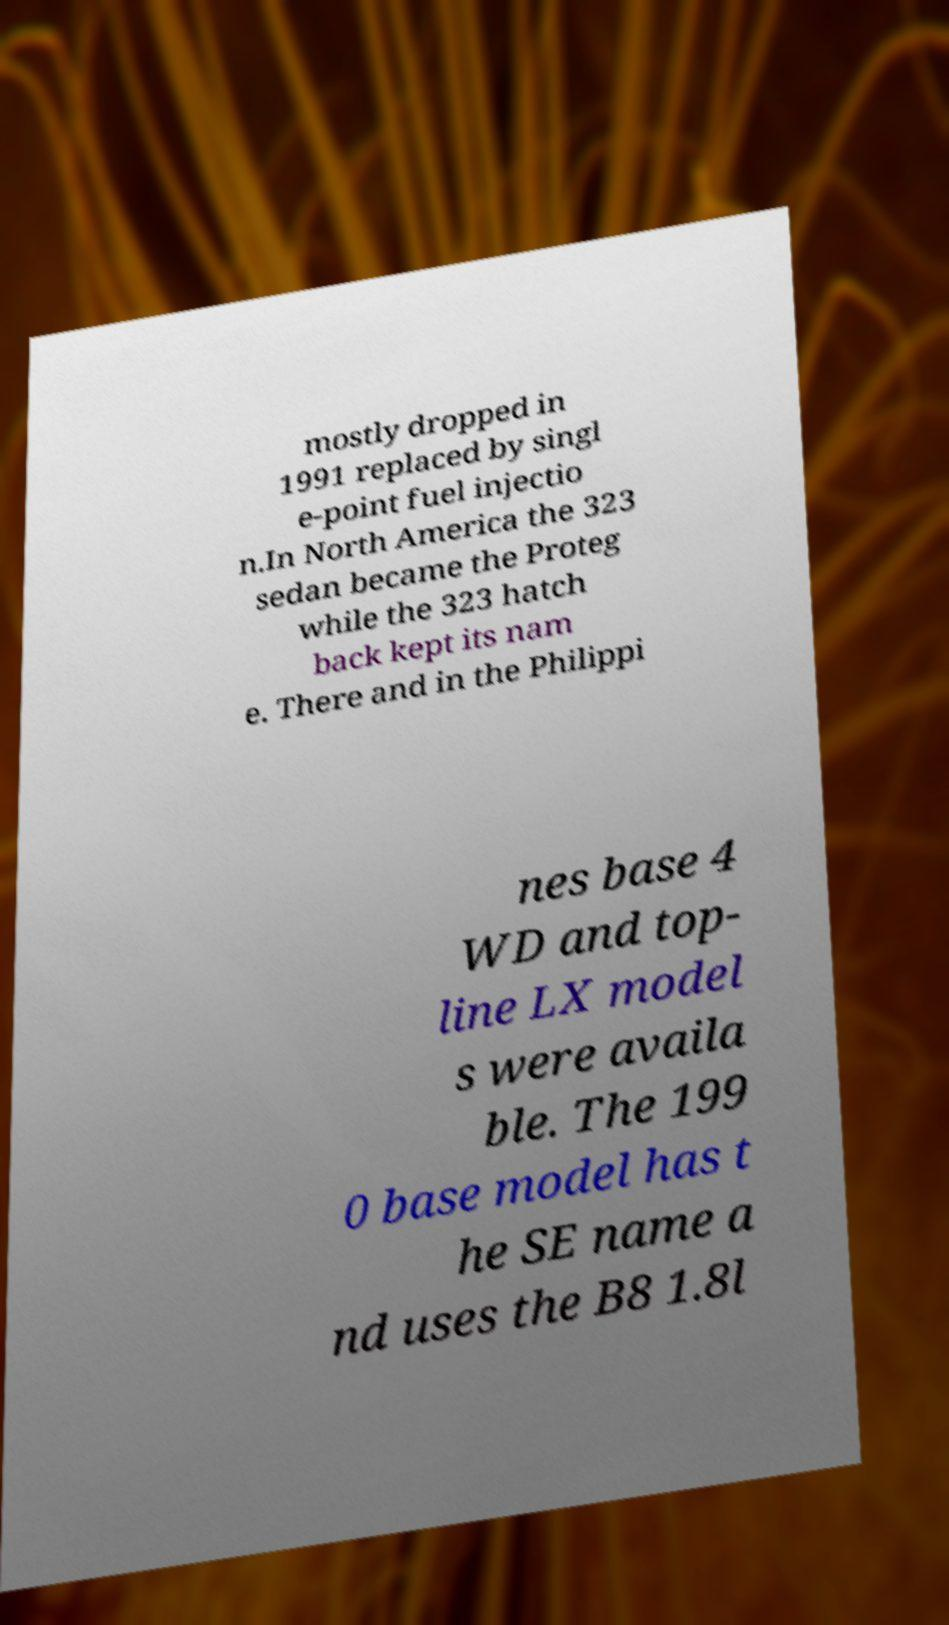There's text embedded in this image that I need extracted. Can you transcribe it verbatim? mostly dropped in 1991 replaced by singl e-point fuel injectio n.In North America the 323 sedan became the Proteg while the 323 hatch back kept its nam e. There and in the Philippi nes base 4 WD and top- line LX model s were availa ble. The 199 0 base model has t he SE name a nd uses the B8 1.8l 